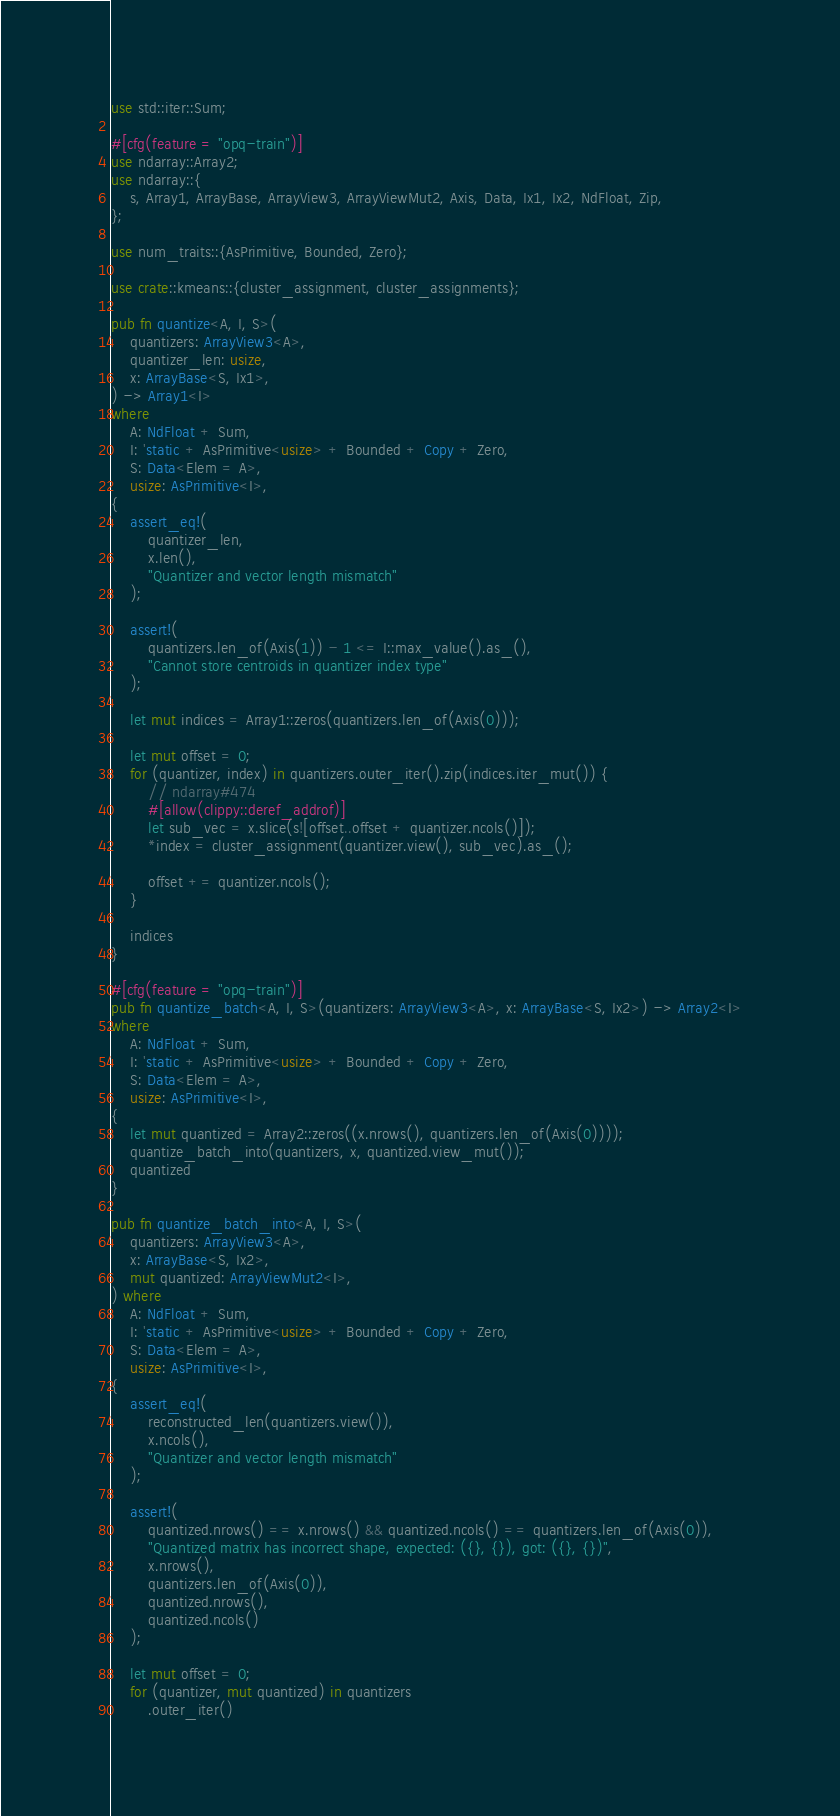<code> <loc_0><loc_0><loc_500><loc_500><_Rust_>use std::iter::Sum;

#[cfg(feature = "opq-train")]
use ndarray::Array2;
use ndarray::{
    s, Array1, ArrayBase, ArrayView3, ArrayViewMut2, Axis, Data, Ix1, Ix2, NdFloat, Zip,
};

use num_traits::{AsPrimitive, Bounded, Zero};

use crate::kmeans::{cluster_assignment, cluster_assignments};

pub fn quantize<A, I, S>(
    quantizers: ArrayView3<A>,
    quantizer_len: usize,
    x: ArrayBase<S, Ix1>,
) -> Array1<I>
where
    A: NdFloat + Sum,
    I: 'static + AsPrimitive<usize> + Bounded + Copy + Zero,
    S: Data<Elem = A>,
    usize: AsPrimitive<I>,
{
    assert_eq!(
        quantizer_len,
        x.len(),
        "Quantizer and vector length mismatch"
    );

    assert!(
        quantizers.len_of(Axis(1)) - 1 <= I::max_value().as_(),
        "Cannot store centroids in quantizer index type"
    );

    let mut indices = Array1::zeros(quantizers.len_of(Axis(0)));

    let mut offset = 0;
    for (quantizer, index) in quantizers.outer_iter().zip(indices.iter_mut()) {
        // ndarray#474
        #[allow(clippy::deref_addrof)]
        let sub_vec = x.slice(s![offset..offset + quantizer.ncols()]);
        *index = cluster_assignment(quantizer.view(), sub_vec).as_();

        offset += quantizer.ncols();
    }

    indices
}

#[cfg(feature = "opq-train")]
pub fn quantize_batch<A, I, S>(quantizers: ArrayView3<A>, x: ArrayBase<S, Ix2>) -> Array2<I>
where
    A: NdFloat + Sum,
    I: 'static + AsPrimitive<usize> + Bounded + Copy + Zero,
    S: Data<Elem = A>,
    usize: AsPrimitive<I>,
{
    let mut quantized = Array2::zeros((x.nrows(), quantizers.len_of(Axis(0))));
    quantize_batch_into(quantizers, x, quantized.view_mut());
    quantized
}

pub fn quantize_batch_into<A, I, S>(
    quantizers: ArrayView3<A>,
    x: ArrayBase<S, Ix2>,
    mut quantized: ArrayViewMut2<I>,
) where
    A: NdFloat + Sum,
    I: 'static + AsPrimitive<usize> + Bounded + Copy + Zero,
    S: Data<Elem = A>,
    usize: AsPrimitive<I>,
{
    assert_eq!(
        reconstructed_len(quantizers.view()),
        x.ncols(),
        "Quantizer and vector length mismatch"
    );

    assert!(
        quantized.nrows() == x.nrows() && quantized.ncols() == quantizers.len_of(Axis(0)),
        "Quantized matrix has incorrect shape, expected: ({}, {}), got: ({}, {})",
        x.nrows(),
        quantizers.len_of(Axis(0)),
        quantized.nrows(),
        quantized.ncols()
    );

    let mut offset = 0;
    for (quantizer, mut quantized) in quantizers
        .outer_iter()</code> 